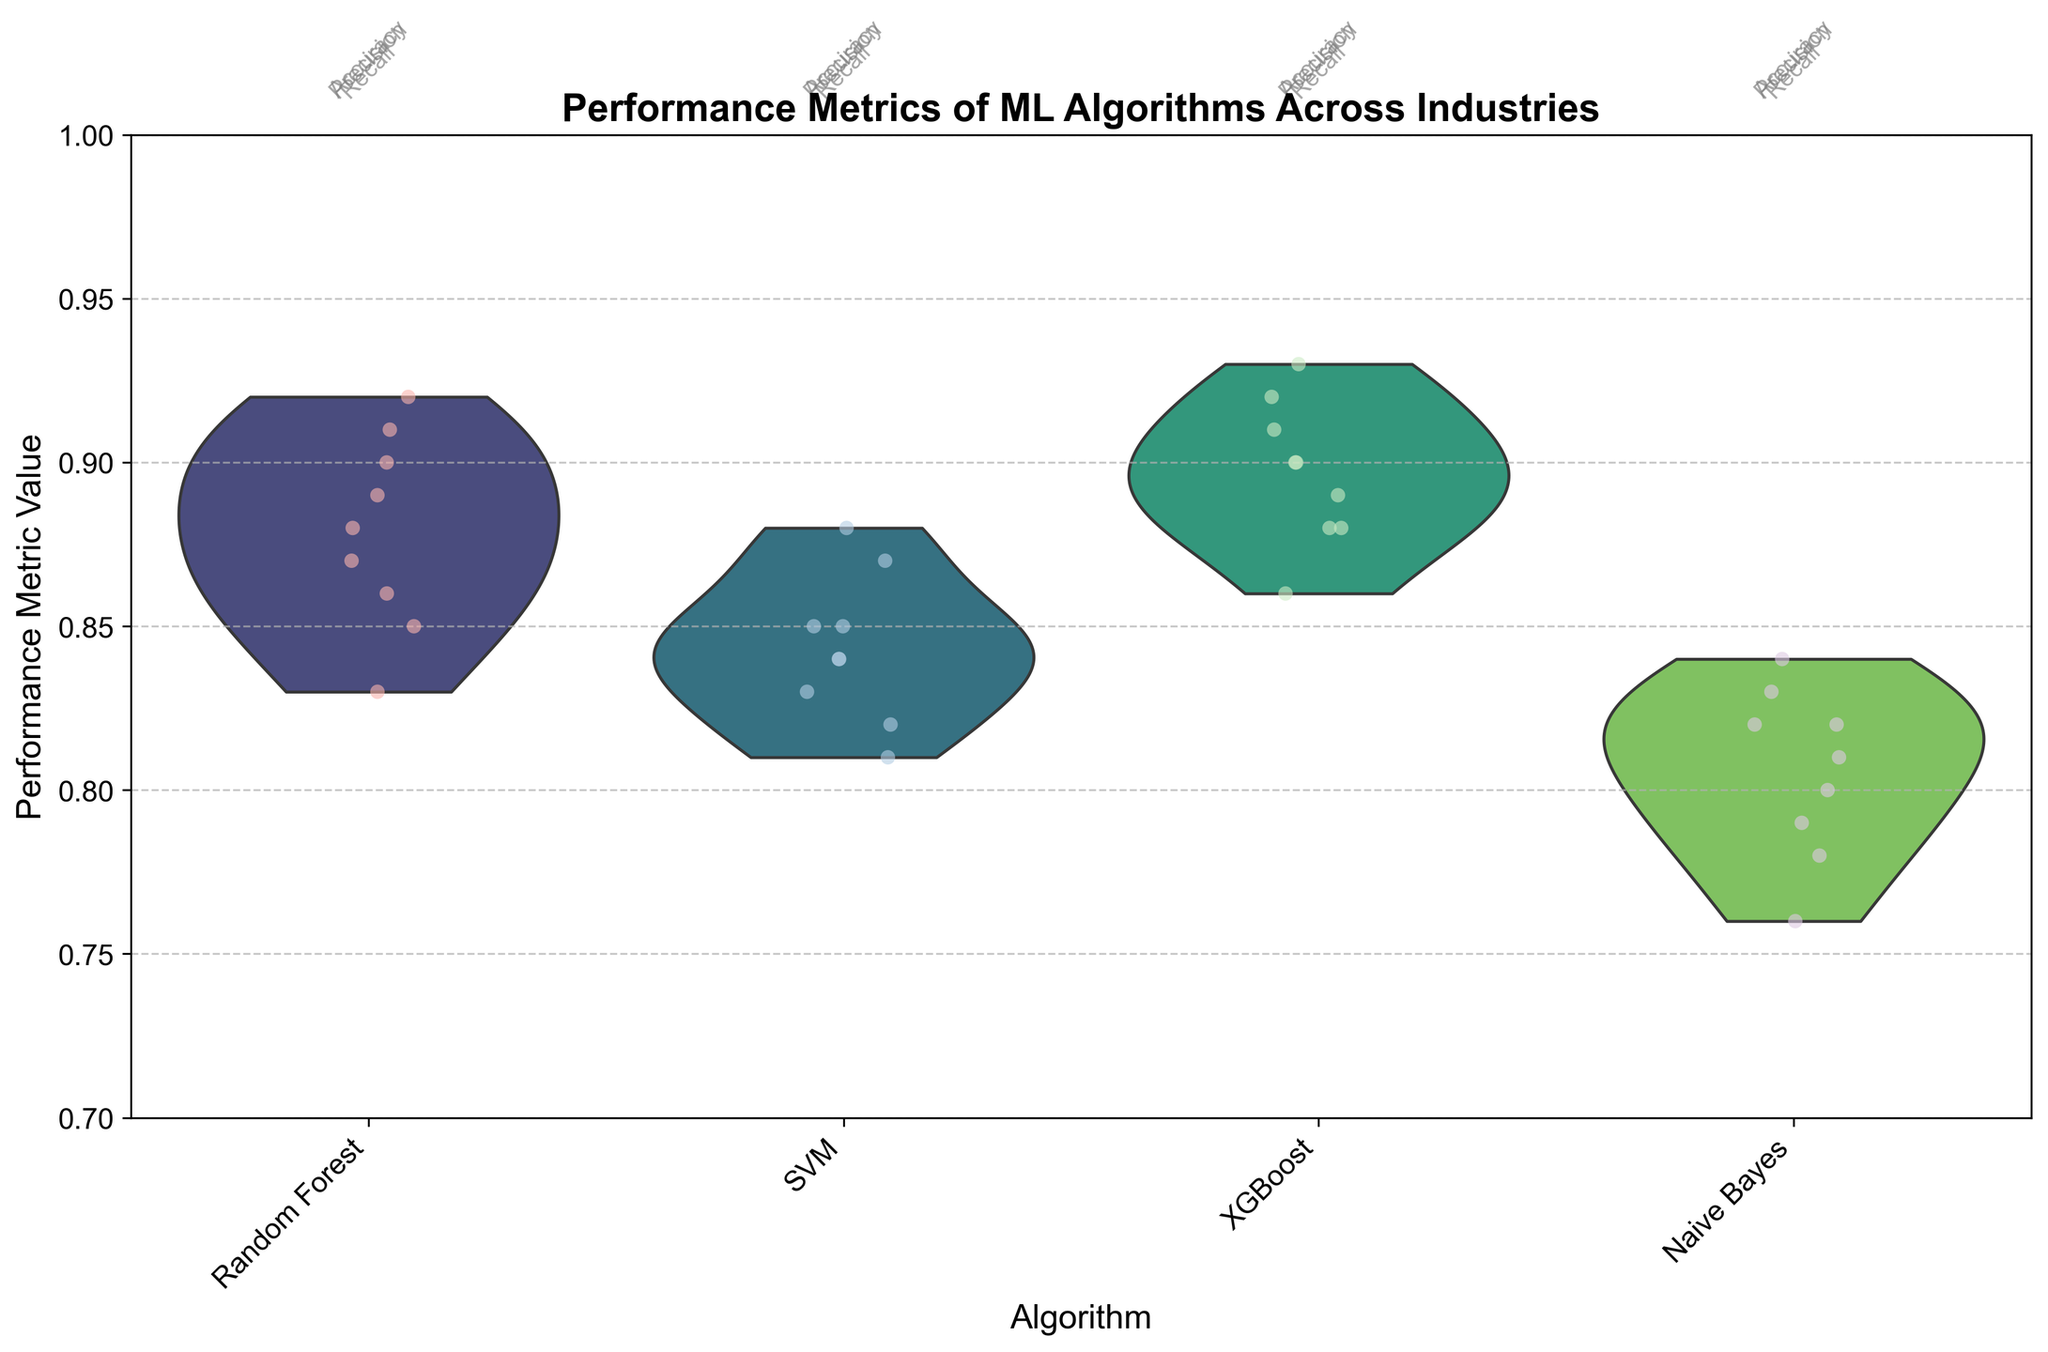What is the title of the chart? The title is usually found at the top of the chart, indicating the main subject. Here, it states "Performance Metrics of ML Algorithms Across Industries".
Answer: Performance Metrics of ML Algorithms Across Industries Which algorithm appears to have the highest median performance metric value? In a violin plot, the median is typically marked with a horizontal line within each violin. By observing the violins, XGBoost consistently appears to have the highest median value across all metrics and industries.
Answer: XGBoost What is the minimum value displayed on the y-axis? The y-axis displays the range of performance metric values, with the minimum value clearly marked at 0.7.
Answer: 0.7 How does the precision of the Naive Bayes algorithm in the healthcare industry compare to its accuracy in the same industry? From the jittered points and their distribution in the violin plot, we can observe Naive Bayes has a lower precision value compared to its accuracy in the healthcare industry.
Answer: Precision is lower than accuracy Which algorithm shows the widest spread of performance values across different metrics and industries? The width of the violins gives us an idea of the spread of the data. Visually, Naive Bayes appears to have a wider distribution indicating more variability in performance metrics across different industries.
Answer: Naive Bayes What is the numerical range of XGBoost's performance metrics? To find the range, we look at the highest and lowest points of the XGBoost violins. The highest is around 0.93 and the lowest is around 0.86. So, the range is 0.93 - 0.86.
Answer: 0.07 Among the displayed metrics (accuracy, precision, recall), which one generally shows higher values for SVM across all industries? By examining the jittered points for SVM, "Accuracy" generally tends to have higher values compared to precision and recall across different industries.
Answer: Accuracy Are there any algorithms with a performance metric value consistently close to the upper limit of the y-axis? Upon inspection, XGBoost often shows performance metric values near 0.93, which is close to the upper limit of the y-axis (1.0).
Answer: XGBoost Which industry shows the least variability in performance metrics for Random Forest? The narrowest violin plot for Random Forest across various industries indicates least variability. The Retail industry shows the least variability.
Answer: Retail How do the performance metrics of Random Forest and XGBoost compare in the finance industry? By comparing the jittered points and violins, XGBoost has higher and less variable performance metric values than Random Forest in the finance industry.
Answer: XGBoost is better 